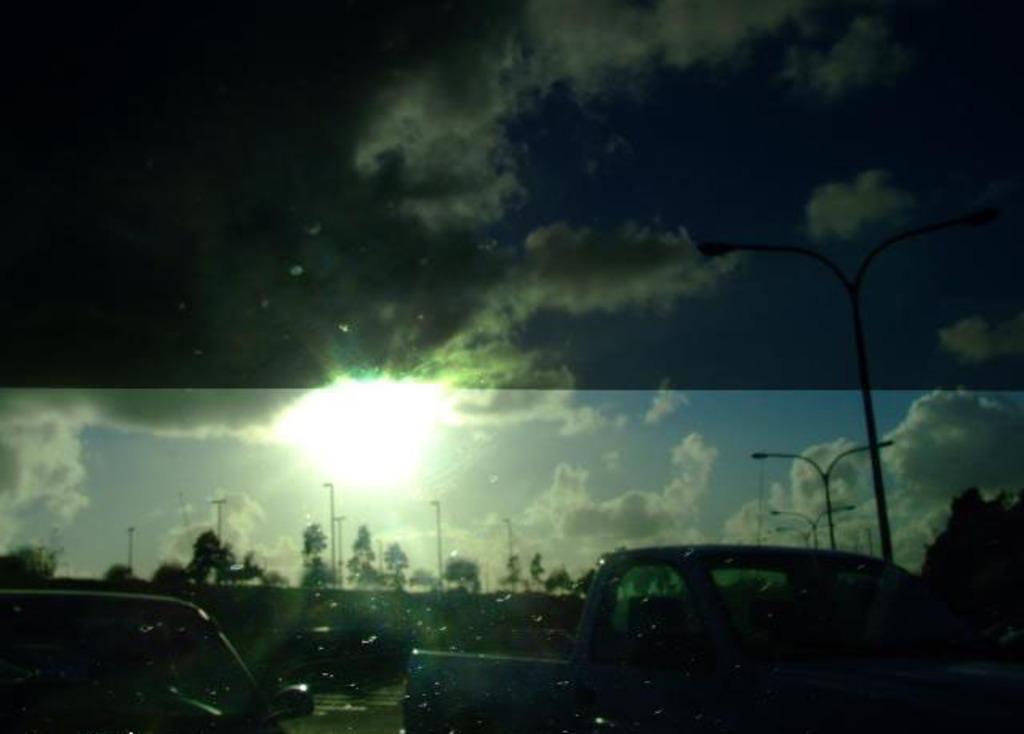Describe this image in one or two sentences. In this picture we can observe some cars on the road. There are some poles to which lights are fixed. In the background there are some trees and sky with some clouds. We can observe sun in the sky. 